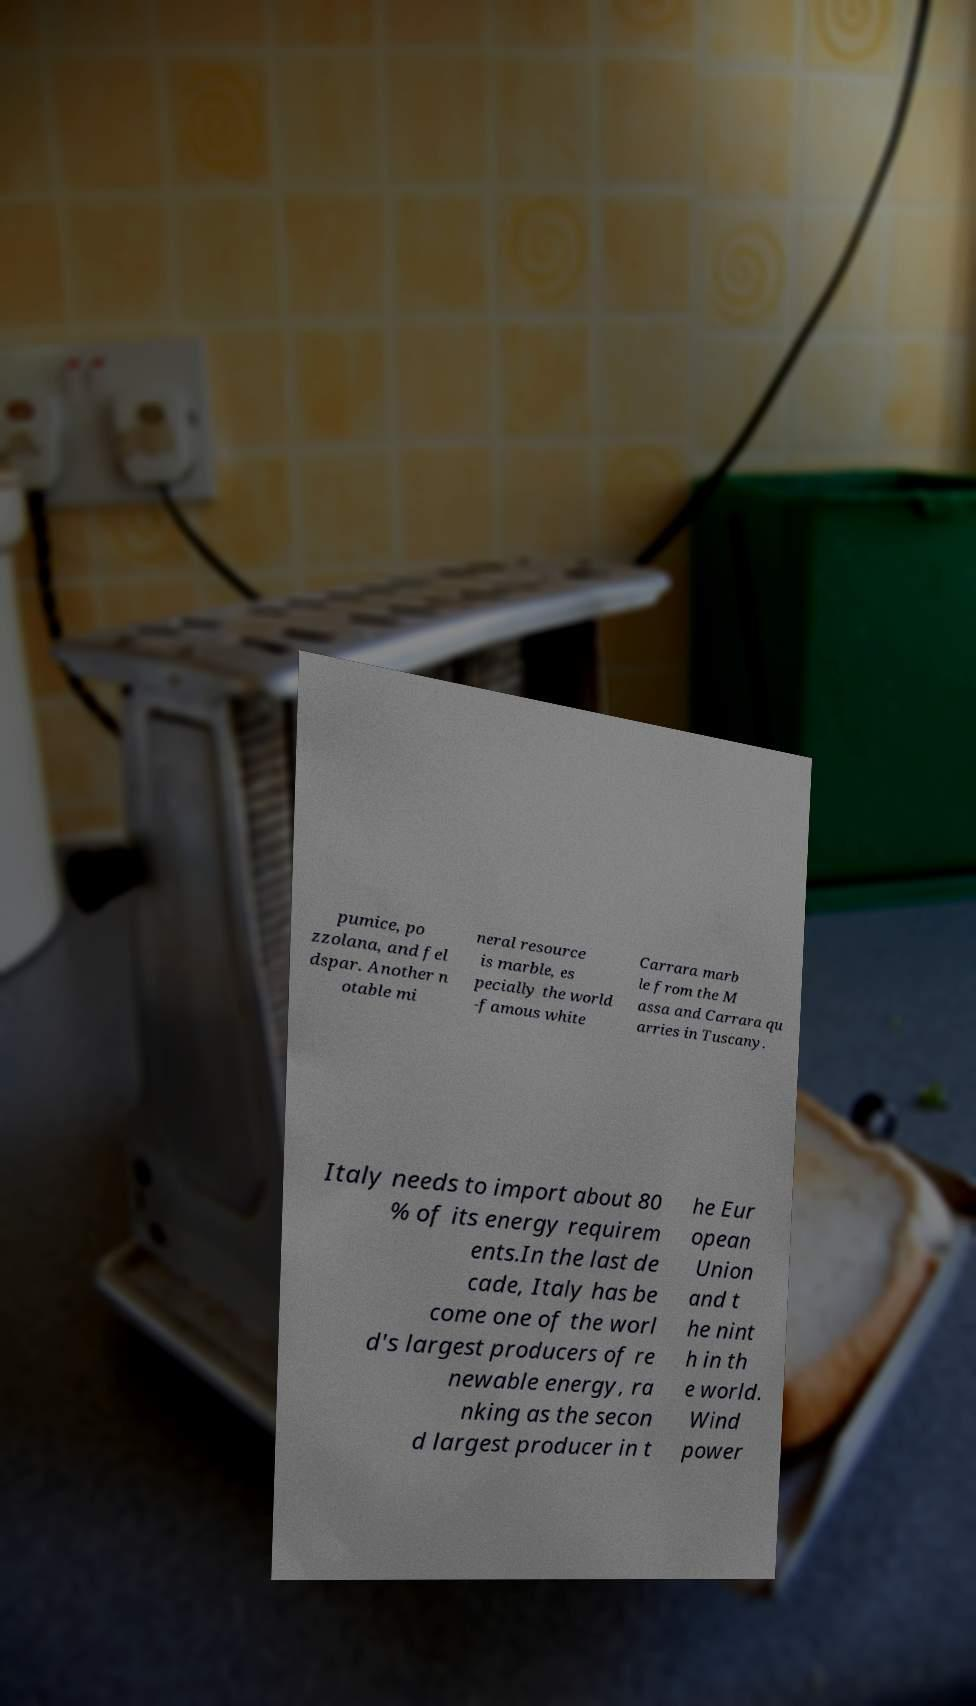Can you read and provide the text displayed in the image?This photo seems to have some interesting text. Can you extract and type it out for me? pumice, po zzolana, and fel dspar. Another n otable mi neral resource is marble, es pecially the world -famous white Carrara marb le from the M assa and Carrara qu arries in Tuscany. Italy needs to import about 80 % of its energy requirem ents.In the last de cade, Italy has be come one of the worl d's largest producers of re newable energy, ra nking as the secon d largest producer in t he Eur opean Union and t he nint h in th e world. Wind power 